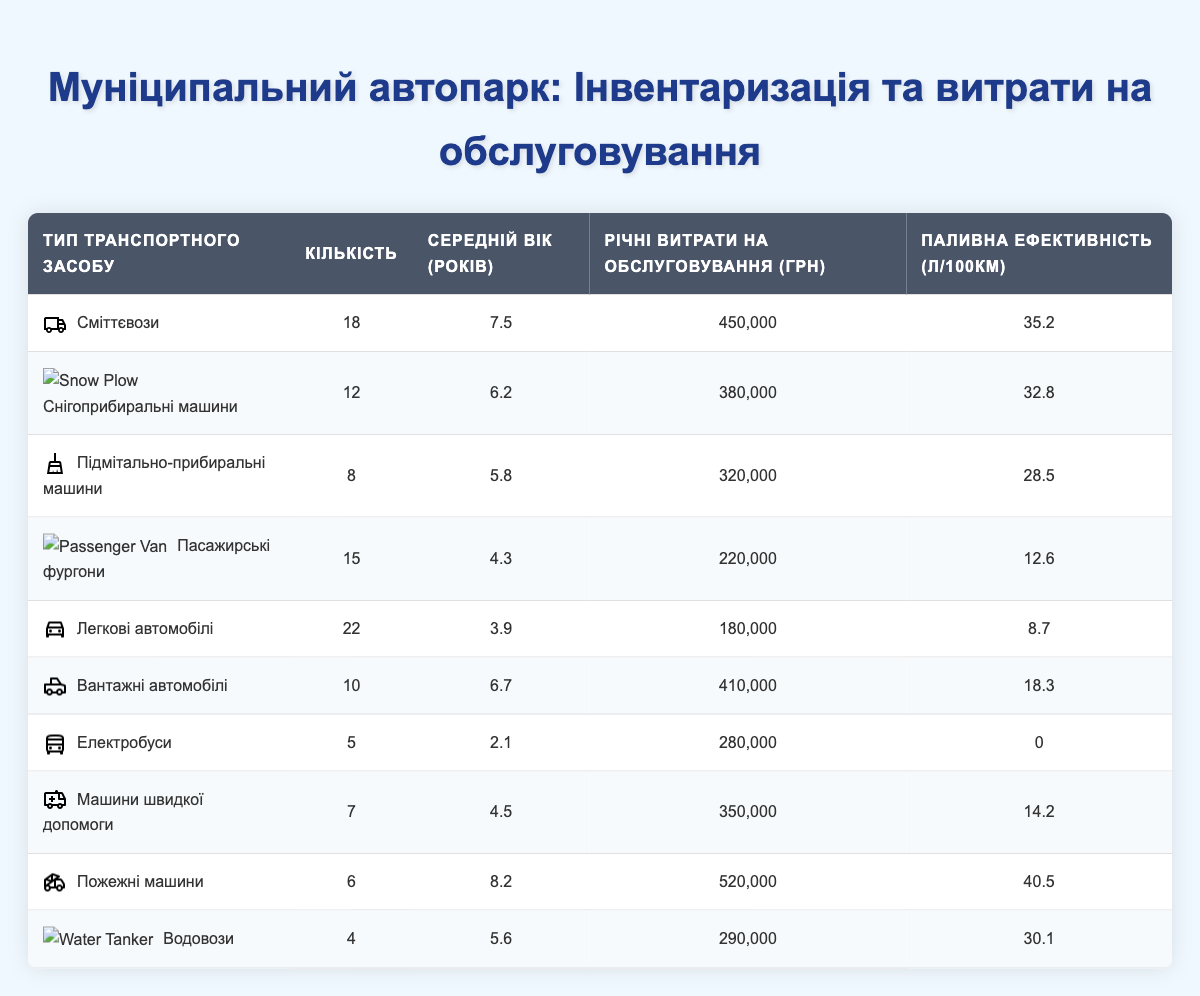What is the total number of vehicles in the fleet? To find the total number of vehicles, sum the quantities in the "Quantity" column from all vehicle types: 18 + 12 + 8 + 15 + 22 + 10 + 5 + 7 + 6 + 4 = 107.
Answer: 107 Which vehicle type has the highest annual maintenance cost? Compare the "Annual Maintenance Cost" column values for all vehicle types. The highest value is 520000 for Fire Trucks.
Answer: Fire Trucks What is the average age of the vehicles in the fleet? To find the average age, sum the "Average Age" values (7.5 + 6.2 + 5.8 + 4.3 + 3.9 + 6.7 + 2.1 + 4.5 + 8.2 + 5.6 = 54.8) and divide by the number of vehicle types (10): 54.8 / 10 = 5.48.
Answer: 5.48 years Are there more Utility Trucks or Sedans in the fleet? Compare the quantities of both vehicles: Utility Trucks have 10 and Sedans have 22. Since 22 is greater than 10, there are more Sedans.
Answer: Yes, there are more Sedans What is the total annual maintenance cost for all Electric Buses? Refer to the "Annual Maintenance Cost" for Electric Buses, which is 280000. Since there are 5 Electric Buses, the total cost is 5 * 280000 = 1400000.
Answer: 1400000 UAH Which vehicle type has the best fuel efficiency? Look at the "Fuel Efficiency" column and find the lowest number. The best fuel efficiency (0 L/100km) is for Electric Buses, as they are electric and do not consume fuel.
Answer: Electric Buses How much more does it cost to maintain a Fire Truck compared to a Passenger Van? Find the annual costs for both: Fire Trucks (520000) and Passenger Vans (220000). Subtract the two: 520000 - 220000 = 300000.
Answer: 300000 UAH What is the average fuel efficiency for the entire fleet? Sum the fuel efficiency values (35.2 + 32.8 + 28.5 + 12.6 + 8.7 + 18.3 + 0 + 14.2 + 40.5 + 30.1 =  306.9) and divide by the number of vehicle types (10): 306.9 / 10 = 30.69.
Answer: 30.69 L/100km Is the average maintenance cost of the Snow Plows higher than that of Passenger Vans? Compare the costs: Snow Plows cost 380000 and Passenger Vans cost 220000. Since 380000 is higher than 220000, the statement is true.
Answer: Yes, it is higher 